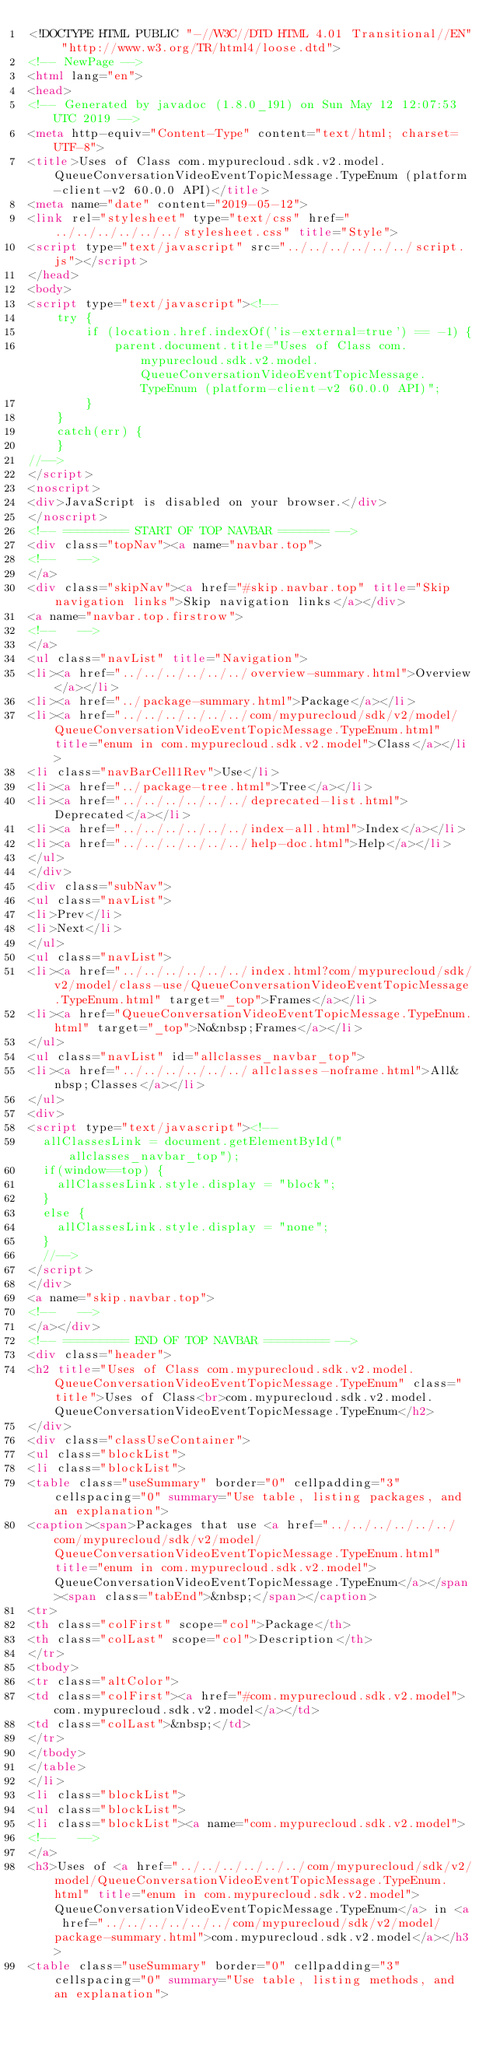Convert code to text. <code><loc_0><loc_0><loc_500><loc_500><_HTML_><!DOCTYPE HTML PUBLIC "-//W3C//DTD HTML 4.01 Transitional//EN" "http://www.w3.org/TR/html4/loose.dtd">
<!-- NewPage -->
<html lang="en">
<head>
<!-- Generated by javadoc (1.8.0_191) on Sun May 12 12:07:53 UTC 2019 -->
<meta http-equiv="Content-Type" content="text/html; charset=UTF-8">
<title>Uses of Class com.mypurecloud.sdk.v2.model.QueueConversationVideoEventTopicMessage.TypeEnum (platform-client-v2 60.0.0 API)</title>
<meta name="date" content="2019-05-12">
<link rel="stylesheet" type="text/css" href="../../../../../../stylesheet.css" title="Style">
<script type="text/javascript" src="../../../../../../script.js"></script>
</head>
<body>
<script type="text/javascript"><!--
    try {
        if (location.href.indexOf('is-external=true') == -1) {
            parent.document.title="Uses of Class com.mypurecloud.sdk.v2.model.QueueConversationVideoEventTopicMessage.TypeEnum (platform-client-v2 60.0.0 API)";
        }
    }
    catch(err) {
    }
//-->
</script>
<noscript>
<div>JavaScript is disabled on your browser.</div>
</noscript>
<!-- ========= START OF TOP NAVBAR ======= -->
<div class="topNav"><a name="navbar.top">
<!--   -->
</a>
<div class="skipNav"><a href="#skip.navbar.top" title="Skip navigation links">Skip navigation links</a></div>
<a name="navbar.top.firstrow">
<!--   -->
</a>
<ul class="navList" title="Navigation">
<li><a href="../../../../../../overview-summary.html">Overview</a></li>
<li><a href="../package-summary.html">Package</a></li>
<li><a href="../../../../../../com/mypurecloud/sdk/v2/model/QueueConversationVideoEventTopicMessage.TypeEnum.html" title="enum in com.mypurecloud.sdk.v2.model">Class</a></li>
<li class="navBarCell1Rev">Use</li>
<li><a href="../package-tree.html">Tree</a></li>
<li><a href="../../../../../../deprecated-list.html">Deprecated</a></li>
<li><a href="../../../../../../index-all.html">Index</a></li>
<li><a href="../../../../../../help-doc.html">Help</a></li>
</ul>
</div>
<div class="subNav">
<ul class="navList">
<li>Prev</li>
<li>Next</li>
</ul>
<ul class="navList">
<li><a href="../../../../../../index.html?com/mypurecloud/sdk/v2/model/class-use/QueueConversationVideoEventTopicMessage.TypeEnum.html" target="_top">Frames</a></li>
<li><a href="QueueConversationVideoEventTopicMessage.TypeEnum.html" target="_top">No&nbsp;Frames</a></li>
</ul>
<ul class="navList" id="allclasses_navbar_top">
<li><a href="../../../../../../allclasses-noframe.html">All&nbsp;Classes</a></li>
</ul>
<div>
<script type="text/javascript"><!--
  allClassesLink = document.getElementById("allclasses_navbar_top");
  if(window==top) {
    allClassesLink.style.display = "block";
  }
  else {
    allClassesLink.style.display = "none";
  }
  //-->
</script>
</div>
<a name="skip.navbar.top">
<!--   -->
</a></div>
<!-- ========= END OF TOP NAVBAR ========= -->
<div class="header">
<h2 title="Uses of Class com.mypurecloud.sdk.v2.model.QueueConversationVideoEventTopicMessage.TypeEnum" class="title">Uses of Class<br>com.mypurecloud.sdk.v2.model.QueueConversationVideoEventTopicMessage.TypeEnum</h2>
</div>
<div class="classUseContainer">
<ul class="blockList">
<li class="blockList">
<table class="useSummary" border="0" cellpadding="3" cellspacing="0" summary="Use table, listing packages, and an explanation">
<caption><span>Packages that use <a href="../../../../../../com/mypurecloud/sdk/v2/model/QueueConversationVideoEventTopicMessage.TypeEnum.html" title="enum in com.mypurecloud.sdk.v2.model">QueueConversationVideoEventTopicMessage.TypeEnum</a></span><span class="tabEnd">&nbsp;</span></caption>
<tr>
<th class="colFirst" scope="col">Package</th>
<th class="colLast" scope="col">Description</th>
</tr>
<tbody>
<tr class="altColor">
<td class="colFirst"><a href="#com.mypurecloud.sdk.v2.model">com.mypurecloud.sdk.v2.model</a></td>
<td class="colLast">&nbsp;</td>
</tr>
</tbody>
</table>
</li>
<li class="blockList">
<ul class="blockList">
<li class="blockList"><a name="com.mypurecloud.sdk.v2.model">
<!--   -->
</a>
<h3>Uses of <a href="../../../../../../com/mypurecloud/sdk/v2/model/QueueConversationVideoEventTopicMessage.TypeEnum.html" title="enum in com.mypurecloud.sdk.v2.model">QueueConversationVideoEventTopicMessage.TypeEnum</a> in <a href="../../../../../../com/mypurecloud/sdk/v2/model/package-summary.html">com.mypurecloud.sdk.v2.model</a></h3>
<table class="useSummary" border="0" cellpadding="3" cellspacing="0" summary="Use table, listing methods, and an explanation"></code> 